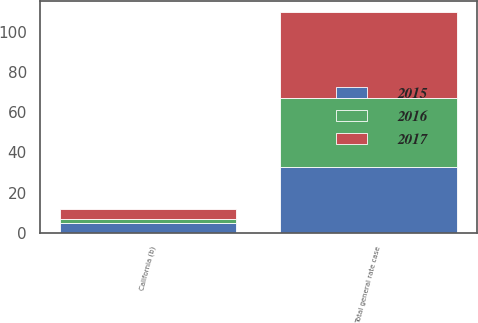Convert chart to OTSL. <chart><loc_0><loc_0><loc_500><loc_500><stacked_bar_chart><ecel><fcel>California (b)<fcel>Total general rate case<nl><fcel>2017<fcel>5<fcel>43<nl><fcel>2016<fcel>2<fcel>34<nl><fcel>2015<fcel>5<fcel>33<nl></chart> 